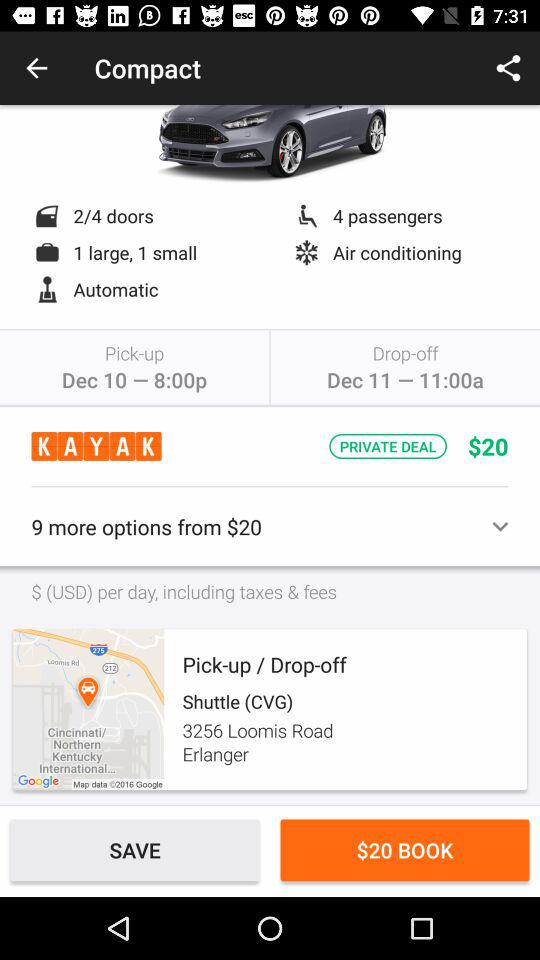What is the booking amount for the trip? The booking amount for the trip is $20. 